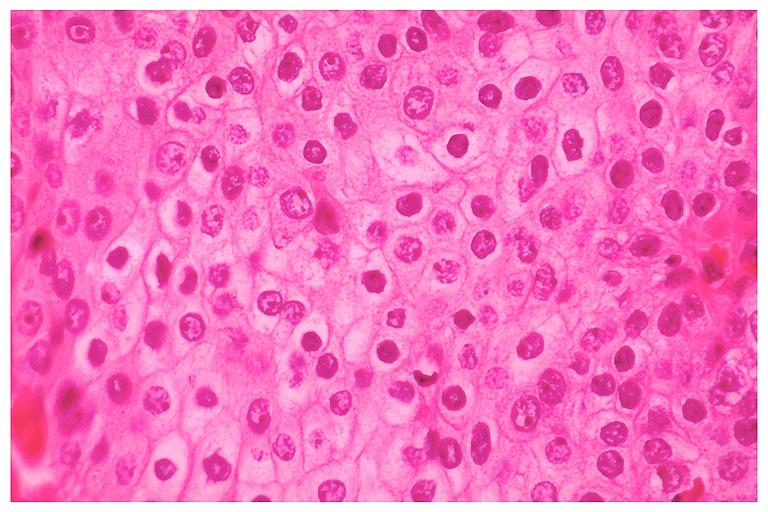what does this image show?
Answer the question using a single word or phrase. Mucoepidermoid carcinoma 